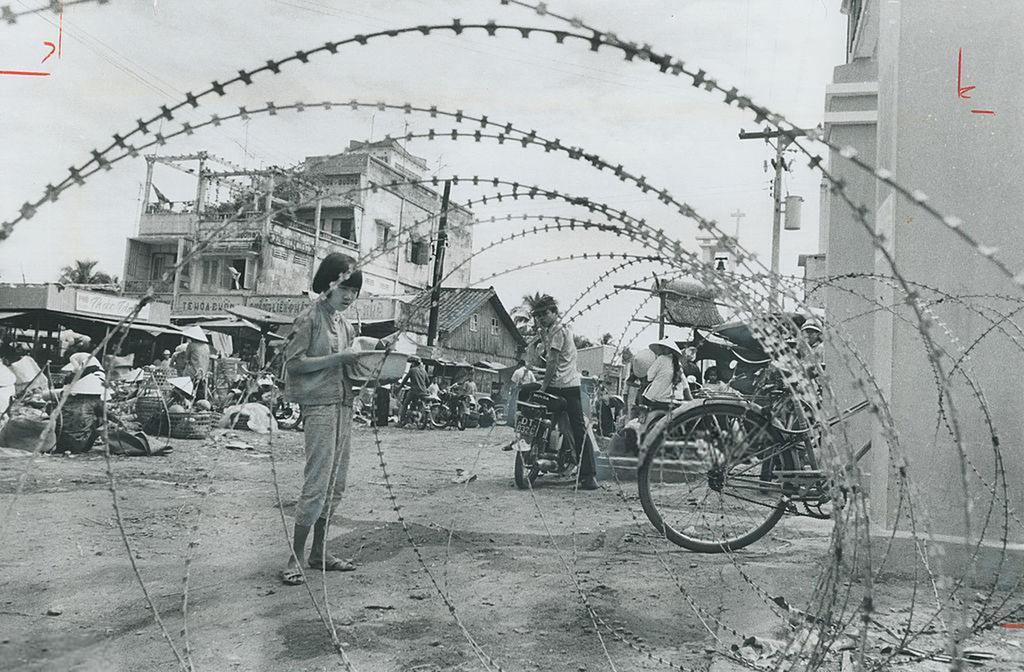Can you describe this image briefly? In this picture we can see people, motorcycles and a bicycle on the ground, here we can see buildings, electric poles and some objects and we can see sky in the background. 